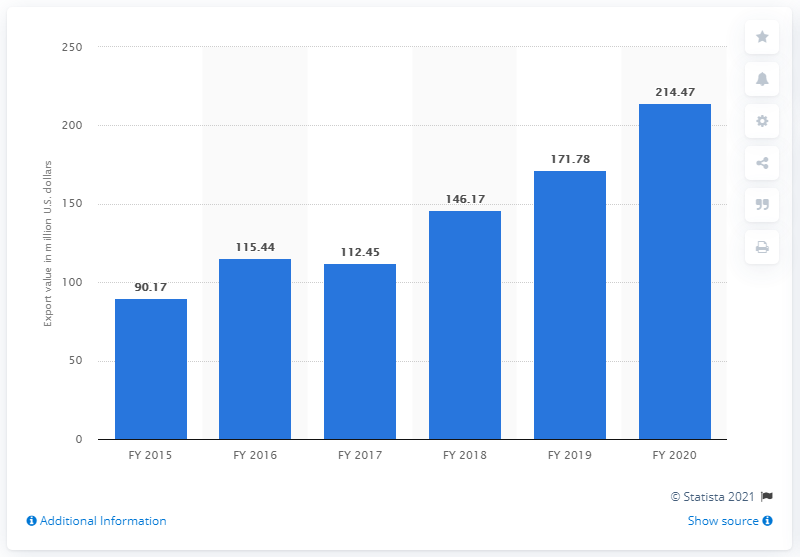Specify some key components in this picture. The export value of essential oils from India in the fiscal year of 2020 was 214.47 million dollars. 